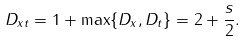<formula> <loc_0><loc_0><loc_500><loc_500>D _ { x t } = 1 + \max \{ D _ { x } , D _ { t } \} = 2 + \frac { s } { 2 } .</formula> 